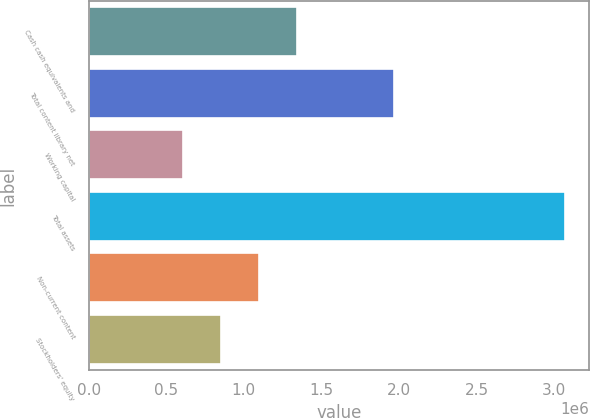<chart> <loc_0><loc_0><loc_500><loc_500><bar_chart><fcel>Cash cash equivalents and<fcel>Total content library net<fcel>Working capital<fcel>Total assets<fcel>Non-current content<fcel>Stockholders' equity<nl><fcel>1.34482e+06<fcel>1.96664e+06<fcel>605802<fcel>3.0692e+06<fcel>1.09848e+06<fcel>852141<nl></chart> 